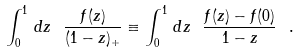Convert formula to latex. <formula><loc_0><loc_0><loc_500><loc_500>\int _ { 0 } ^ { 1 } \, d z \ \frac { f ( z ) } { ( 1 - z ) _ { + } } \equiv \int _ { 0 } ^ { 1 } \, d z \ \frac { f ( z ) - f ( 0 ) } { 1 - z } \ .</formula> 